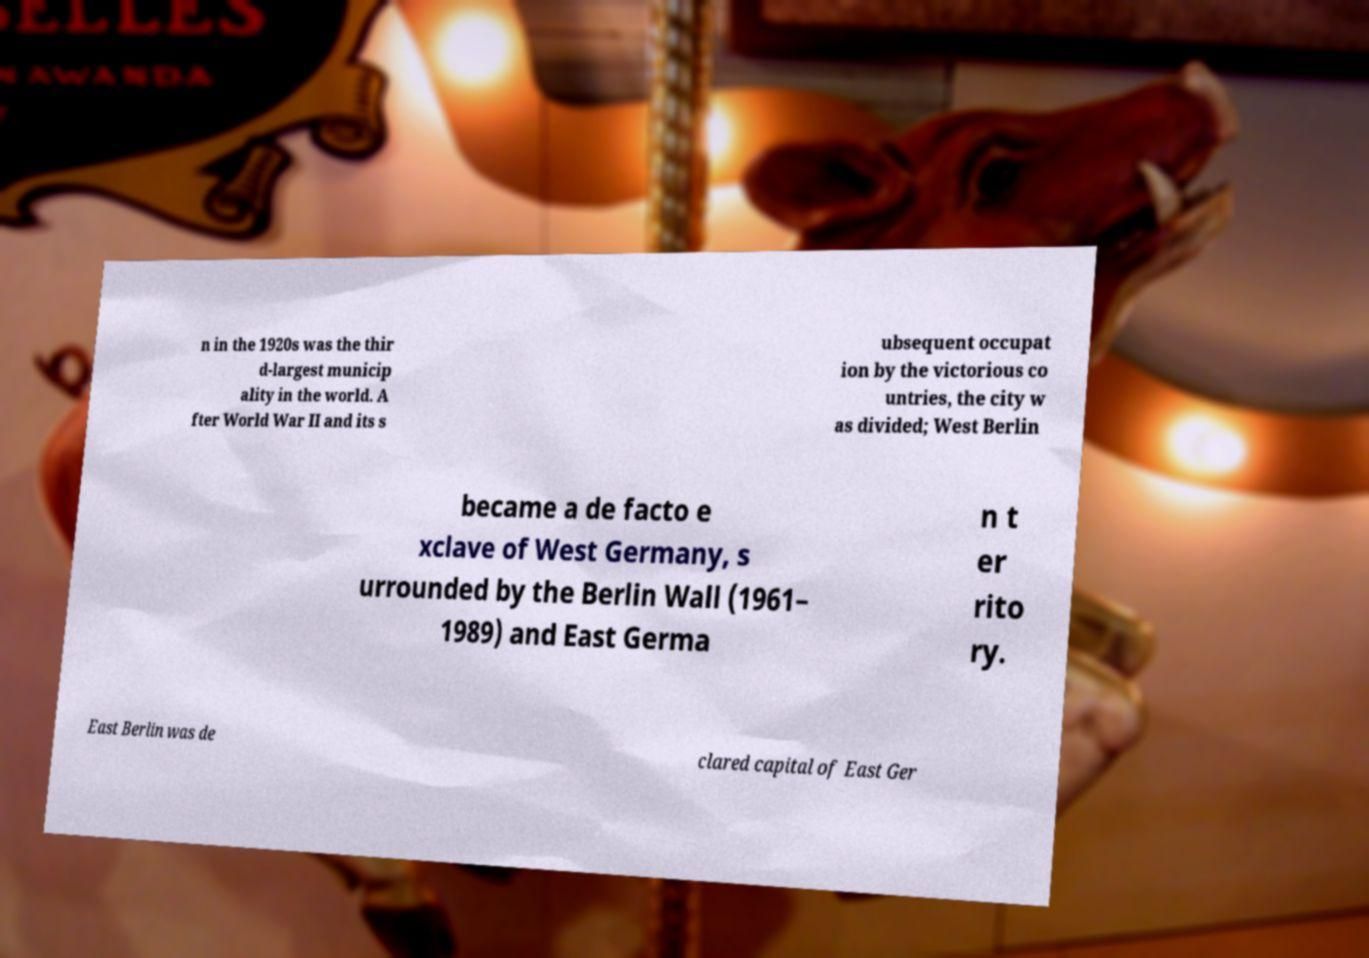What messages or text are displayed in this image? I need them in a readable, typed format. n in the 1920s was the thir d-largest municip ality in the world. A fter World War II and its s ubsequent occupat ion by the victorious co untries, the city w as divided; West Berlin became a de facto e xclave of West Germany, s urrounded by the Berlin Wall (1961– 1989) and East Germa n t er rito ry. East Berlin was de clared capital of East Ger 